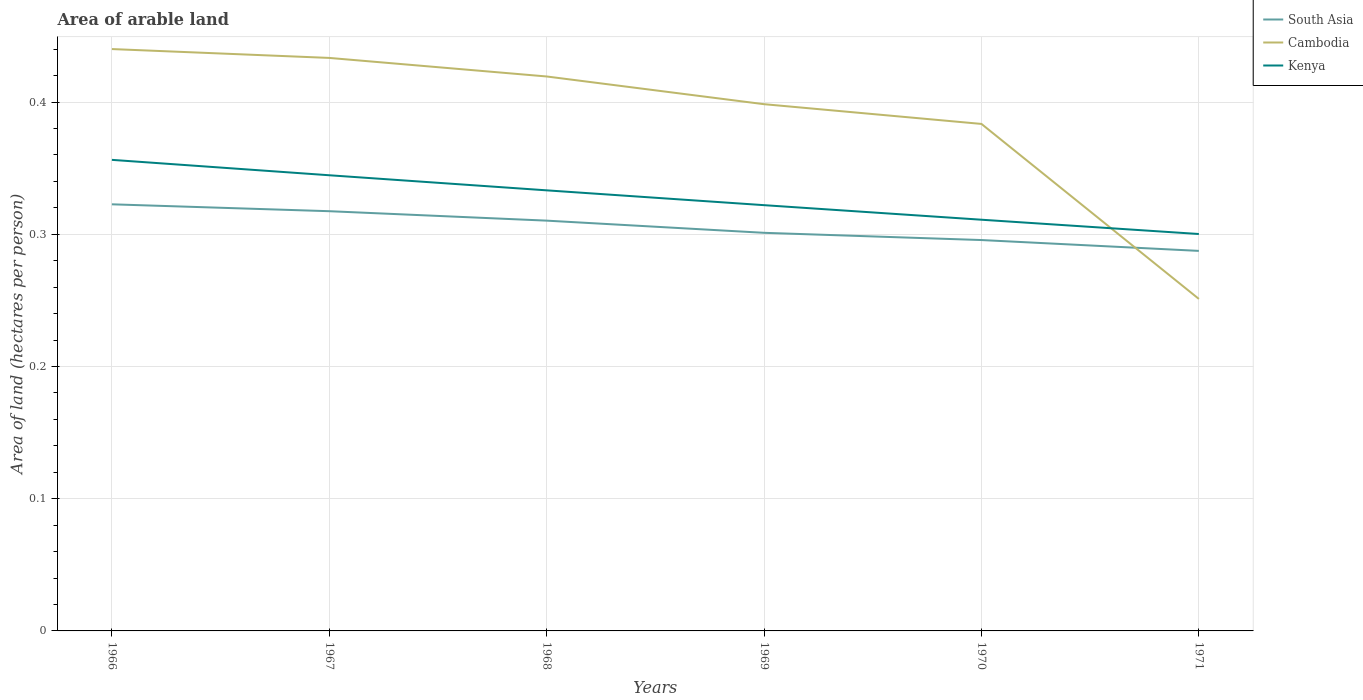Does the line corresponding to Kenya intersect with the line corresponding to South Asia?
Offer a very short reply. No. Across all years, what is the maximum total arable land in South Asia?
Your answer should be compact. 0.29. In which year was the total arable land in Kenya maximum?
Your answer should be compact. 1971. What is the total total arable land in South Asia in the graph?
Your response must be concise. 0.04. What is the difference between the highest and the second highest total arable land in Kenya?
Offer a very short reply. 0.06. Is the total arable land in Kenya strictly greater than the total arable land in Cambodia over the years?
Your response must be concise. No. How many lines are there?
Your response must be concise. 3. How many years are there in the graph?
Keep it short and to the point. 6. Does the graph contain grids?
Provide a short and direct response. Yes. Where does the legend appear in the graph?
Ensure brevity in your answer.  Top right. How are the legend labels stacked?
Provide a succinct answer. Vertical. What is the title of the graph?
Ensure brevity in your answer.  Area of arable land. Does "Pacific island small states" appear as one of the legend labels in the graph?
Offer a terse response. No. What is the label or title of the X-axis?
Your answer should be very brief. Years. What is the label or title of the Y-axis?
Your response must be concise. Area of land (hectares per person). What is the Area of land (hectares per person) in South Asia in 1966?
Offer a very short reply. 0.32. What is the Area of land (hectares per person) in Cambodia in 1966?
Ensure brevity in your answer.  0.44. What is the Area of land (hectares per person) of Kenya in 1966?
Make the answer very short. 0.36. What is the Area of land (hectares per person) of South Asia in 1967?
Ensure brevity in your answer.  0.32. What is the Area of land (hectares per person) in Cambodia in 1967?
Offer a terse response. 0.43. What is the Area of land (hectares per person) in Kenya in 1967?
Offer a very short reply. 0.34. What is the Area of land (hectares per person) in South Asia in 1968?
Your answer should be compact. 0.31. What is the Area of land (hectares per person) of Cambodia in 1968?
Keep it short and to the point. 0.42. What is the Area of land (hectares per person) of Kenya in 1968?
Your answer should be compact. 0.33. What is the Area of land (hectares per person) in South Asia in 1969?
Offer a very short reply. 0.3. What is the Area of land (hectares per person) of Cambodia in 1969?
Give a very brief answer. 0.4. What is the Area of land (hectares per person) in Kenya in 1969?
Offer a very short reply. 0.32. What is the Area of land (hectares per person) of South Asia in 1970?
Ensure brevity in your answer.  0.3. What is the Area of land (hectares per person) in Cambodia in 1970?
Your answer should be compact. 0.38. What is the Area of land (hectares per person) in Kenya in 1970?
Your answer should be very brief. 0.31. What is the Area of land (hectares per person) in South Asia in 1971?
Provide a short and direct response. 0.29. What is the Area of land (hectares per person) of Cambodia in 1971?
Offer a very short reply. 0.25. What is the Area of land (hectares per person) in Kenya in 1971?
Ensure brevity in your answer.  0.3. Across all years, what is the maximum Area of land (hectares per person) in South Asia?
Keep it short and to the point. 0.32. Across all years, what is the maximum Area of land (hectares per person) in Cambodia?
Provide a short and direct response. 0.44. Across all years, what is the maximum Area of land (hectares per person) in Kenya?
Your answer should be compact. 0.36. Across all years, what is the minimum Area of land (hectares per person) in South Asia?
Provide a short and direct response. 0.29. Across all years, what is the minimum Area of land (hectares per person) of Cambodia?
Your answer should be compact. 0.25. Across all years, what is the minimum Area of land (hectares per person) in Kenya?
Offer a very short reply. 0.3. What is the total Area of land (hectares per person) of South Asia in the graph?
Offer a very short reply. 1.83. What is the total Area of land (hectares per person) of Cambodia in the graph?
Provide a short and direct response. 2.33. What is the total Area of land (hectares per person) of Kenya in the graph?
Your response must be concise. 1.97. What is the difference between the Area of land (hectares per person) of South Asia in 1966 and that in 1967?
Your answer should be very brief. 0.01. What is the difference between the Area of land (hectares per person) in Cambodia in 1966 and that in 1967?
Keep it short and to the point. 0.01. What is the difference between the Area of land (hectares per person) of Kenya in 1966 and that in 1967?
Offer a terse response. 0.01. What is the difference between the Area of land (hectares per person) in South Asia in 1966 and that in 1968?
Your answer should be compact. 0.01. What is the difference between the Area of land (hectares per person) of Cambodia in 1966 and that in 1968?
Provide a short and direct response. 0.02. What is the difference between the Area of land (hectares per person) in Kenya in 1966 and that in 1968?
Offer a terse response. 0.02. What is the difference between the Area of land (hectares per person) in South Asia in 1966 and that in 1969?
Provide a succinct answer. 0.02. What is the difference between the Area of land (hectares per person) of Cambodia in 1966 and that in 1969?
Your answer should be very brief. 0.04. What is the difference between the Area of land (hectares per person) of Kenya in 1966 and that in 1969?
Make the answer very short. 0.03. What is the difference between the Area of land (hectares per person) in South Asia in 1966 and that in 1970?
Provide a succinct answer. 0.03. What is the difference between the Area of land (hectares per person) in Cambodia in 1966 and that in 1970?
Offer a very short reply. 0.06. What is the difference between the Area of land (hectares per person) in Kenya in 1966 and that in 1970?
Make the answer very short. 0.05. What is the difference between the Area of land (hectares per person) in South Asia in 1966 and that in 1971?
Keep it short and to the point. 0.04. What is the difference between the Area of land (hectares per person) of Cambodia in 1966 and that in 1971?
Your answer should be very brief. 0.19. What is the difference between the Area of land (hectares per person) in Kenya in 1966 and that in 1971?
Offer a terse response. 0.06. What is the difference between the Area of land (hectares per person) in South Asia in 1967 and that in 1968?
Make the answer very short. 0.01. What is the difference between the Area of land (hectares per person) in Cambodia in 1967 and that in 1968?
Keep it short and to the point. 0.01. What is the difference between the Area of land (hectares per person) in Kenya in 1967 and that in 1968?
Your response must be concise. 0.01. What is the difference between the Area of land (hectares per person) in South Asia in 1967 and that in 1969?
Give a very brief answer. 0.02. What is the difference between the Area of land (hectares per person) of Cambodia in 1967 and that in 1969?
Your answer should be compact. 0.04. What is the difference between the Area of land (hectares per person) of Kenya in 1967 and that in 1969?
Your answer should be very brief. 0.02. What is the difference between the Area of land (hectares per person) in South Asia in 1967 and that in 1970?
Provide a succinct answer. 0.02. What is the difference between the Area of land (hectares per person) of Cambodia in 1967 and that in 1970?
Provide a succinct answer. 0.05. What is the difference between the Area of land (hectares per person) of Kenya in 1967 and that in 1970?
Your answer should be compact. 0.03. What is the difference between the Area of land (hectares per person) of Cambodia in 1967 and that in 1971?
Offer a very short reply. 0.18. What is the difference between the Area of land (hectares per person) in Kenya in 1967 and that in 1971?
Give a very brief answer. 0.04. What is the difference between the Area of land (hectares per person) in South Asia in 1968 and that in 1969?
Offer a very short reply. 0.01. What is the difference between the Area of land (hectares per person) in Cambodia in 1968 and that in 1969?
Your response must be concise. 0.02. What is the difference between the Area of land (hectares per person) in Kenya in 1968 and that in 1969?
Keep it short and to the point. 0.01. What is the difference between the Area of land (hectares per person) in South Asia in 1968 and that in 1970?
Ensure brevity in your answer.  0.01. What is the difference between the Area of land (hectares per person) in Cambodia in 1968 and that in 1970?
Make the answer very short. 0.04. What is the difference between the Area of land (hectares per person) in Kenya in 1968 and that in 1970?
Ensure brevity in your answer.  0.02. What is the difference between the Area of land (hectares per person) in South Asia in 1968 and that in 1971?
Provide a succinct answer. 0.02. What is the difference between the Area of land (hectares per person) of Cambodia in 1968 and that in 1971?
Offer a terse response. 0.17. What is the difference between the Area of land (hectares per person) of Kenya in 1968 and that in 1971?
Your response must be concise. 0.03. What is the difference between the Area of land (hectares per person) of South Asia in 1969 and that in 1970?
Provide a short and direct response. 0.01. What is the difference between the Area of land (hectares per person) in Cambodia in 1969 and that in 1970?
Your answer should be compact. 0.01. What is the difference between the Area of land (hectares per person) of Kenya in 1969 and that in 1970?
Offer a very short reply. 0.01. What is the difference between the Area of land (hectares per person) of South Asia in 1969 and that in 1971?
Make the answer very short. 0.01. What is the difference between the Area of land (hectares per person) of Cambodia in 1969 and that in 1971?
Provide a short and direct response. 0.15. What is the difference between the Area of land (hectares per person) in Kenya in 1969 and that in 1971?
Ensure brevity in your answer.  0.02. What is the difference between the Area of land (hectares per person) in South Asia in 1970 and that in 1971?
Provide a succinct answer. 0.01. What is the difference between the Area of land (hectares per person) in Cambodia in 1970 and that in 1971?
Give a very brief answer. 0.13. What is the difference between the Area of land (hectares per person) in Kenya in 1970 and that in 1971?
Offer a very short reply. 0.01. What is the difference between the Area of land (hectares per person) of South Asia in 1966 and the Area of land (hectares per person) of Cambodia in 1967?
Keep it short and to the point. -0.11. What is the difference between the Area of land (hectares per person) of South Asia in 1966 and the Area of land (hectares per person) of Kenya in 1967?
Offer a terse response. -0.02. What is the difference between the Area of land (hectares per person) of Cambodia in 1966 and the Area of land (hectares per person) of Kenya in 1967?
Your answer should be compact. 0.1. What is the difference between the Area of land (hectares per person) of South Asia in 1966 and the Area of land (hectares per person) of Cambodia in 1968?
Provide a short and direct response. -0.1. What is the difference between the Area of land (hectares per person) of South Asia in 1966 and the Area of land (hectares per person) of Kenya in 1968?
Make the answer very short. -0.01. What is the difference between the Area of land (hectares per person) of Cambodia in 1966 and the Area of land (hectares per person) of Kenya in 1968?
Keep it short and to the point. 0.11. What is the difference between the Area of land (hectares per person) in South Asia in 1966 and the Area of land (hectares per person) in Cambodia in 1969?
Provide a short and direct response. -0.08. What is the difference between the Area of land (hectares per person) in South Asia in 1966 and the Area of land (hectares per person) in Kenya in 1969?
Ensure brevity in your answer.  0. What is the difference between the Area of land (hectares per person) of Cambodia in 1966 and the Area of land (hectares per person) of Kenya in 1969?
Offer a terse response. 0.12. What is the difference between the Area of land (hectares per person) in South Asia in 1966 and the Area of land (hectares per person) in Cambodia in 1970?
Make the answer very short. -0.06. What is the difference between the Area of land (hectares per person) of South Asia in 1966 and the Area of land (hectares per person) of Kenya in 1970?
Provide a succinct answer. 0.01. What is the difference between the Area of land (hectares per person) in Cambodia in 1966 and the Area of land (hectares per person) in Kenya in 1970?
Provide a short and direct response. 0.13. What is the difference between the Area of land (hectares per person) of South Asia in 1966 and the Area of land (hectares per person) of Cambodia in 1971?
Provide a succinct answer. 0.07. What is the difference between the Area of land (hectares per person) of South Asia in 1966 and the Area of land (hectares per person) of Kenya in 1971?
Offer a very short reply. 0.02. What is the difference between the Area of land (hectares per person) in Cambodia in 1966 and the Area of land (hectares per person) in Kenya in 1971?
Your answer should be very brief. 0.14. What is the difference between the Area of land (hectares per person) of South Asia in 1967 and the Area of land (hectares per person) of Cambodia in 1968?
Provide a succinct answer. -0.1. What is the difference between the Area of land (hectares per person) in South Asia in 1967 and the Area of land (hectares per person) in Kenya in 1968?
Offer a very short reply. -0.02. What is the difference between the Area of land (hectares per person) of Cambodia in 1967 and the Area of land (hectares per person) of Kenya in 1968?
Your answer should be compact. 0.1. What is the difference between the Area of land (hectares per person) of South Asia in 1967 and the Area of land (hectares per person) of Cambodia in 1969?
Make the answer very short. -0.08. What is the difference between the Area of land (hectares per person) in South Asia in 1967 and the Area of land (hectares per person) in Kenya in 1969?
Give a very brief answer. -0. What is the difference between the Area of land (hectares per person) of Cambodia in 1967 and the Area of land (hectares per person) of Kenya in 1969?
Make the answer very short. 0.11. What is the difference between the Area of land (hectares per person) in South Asia in 1967 and the Area of land (hectares per person) in Cambodia in 1970?
Your answer should be compact. -0.07. What is the difference between the Area of land (hectares per person) of South Asia in 1967 and the Area of land (hectares per person) of Kenya in 1970?
Ensure brevity in your answer.  0.01. What is the difference between the Area of land (hectares per person) in Cambodia in 1967 and the Area of land (hectares per person) in Kenya in 1970?
Offer a very short reply. 0.12. What is the difference between the Area of land (hectares per person) of South Asia in 1967 and the Area of land (hectares per person) of Cambodia in 1971?
Keep it short and to the point. 0.07. What is the difference between the Area of land (hectares per person) in South Asia in 1967 and the Area of land (hectares per person) in Kenya in 1971?
Keep it short and to the point. 0.02. What is the difference between the Area of land (hectares per person) of Cambodia in 1967 and the Area of land (hectares per person) of Kenya in 1971?
Offer a terse response. 0.13. What is the difference between the Area of land (hectares per person) of South Asia in 1968 and the Area of land (hectares per person) of Cambodia in 1969?
Make the answer very short. -0.09. What is the difference between the Area of land (hectares per person) of South Asia in 1968 and the Area of land (hectares per person) of Kenya in 1969?
Your response must be concise. -0.01. What is the difference between the Area of land (hectares per person) in Cambodia in 1968 and the Area of land (hectares per person) in Kenya in 1969?
Offer a very short reply. 0.1. What is the difference between the Area of land (hectares per person) of South Asia in 1968 and the Area of land (hectares per person) of Cambodia in 1970?
Give a very brief answer. -0.07. What is the difference between the Area of land (hectares per person) of South Asia in 1968 and the Area of land (hectares per person) of Kenya in 1970?
Offer a terse response. -0. What is the difference between the Area of land (hectares per person) of Cambodia in 1968 and the Area of land (hectares per person) of Kenya in 1970?
Provide a succinct answer. 0.11. What is the difference between the Area of land (hectares per person) in South Asia in 1968 and the Area of land (hectares per person) in Cambodia in 1971?
Offer a very short reply. 0.06. What is the difference between the Area of land (hectares per person) of South Asia in 1968 and the Area of land (hectares per person) of Kenya in 1971?
Your answer should be compact. 0.01. What is the difference between the Area of land (hectares per person) of Cambodia in 1968 and the Area of land (hectares per person) of Kenya in 1971?
Provide a short and direct response. 0.12. What is the difference between the Area of land (hectares per person) of South Asia in 1969 and the Area of land (hectares per person) of Cambodia in 1970?
Offer a terse response. -0.08. What is the difference between the Area of land (hectares per person) of South Asia in 1969 and the Area of land (hectares per person) of Kenya in 1970?
Provide a short and direct response. -0.01. What is the difference between the Area of land (hectares per person) in Cambodia in 1969 and the Area of land (hectares per person) in Kenya in 1970?
Make the answer very short. 0.09. What is the difference between the Area of land (hectares per person) in South Asia in 1969 and the Area of land (hectares per person) in Cambodia in 1971?
Offer a terse response. 0.05. What is the difference between the Area of land (hectares per person) in South Asia in 1969 and the Area of land (hectares per person) in Kenya in 1971?
Your answer should be compact. 0. What is the difference between the Area of land (hectares per person) of Cambodia in 1969 and the Area of land (hectares per person) of Kenya in 1971?
Your answer should be compact. 0.1. What is the difference between the Area of land (hectares per person) of South Asia in 1970 and the Area of land (hectares per person) of Cambodia in 1971?
Your response must be concise. 0.04. What is the difference between the Area of land (hectares per person) of South Asia in 1970 and the Area of land (hectares per person) of Kenya in 1971?
Your answer should be compact. -0. What is the difference between the Area of land (hectares per person) of Cambodia in 1970 and the Area of land (hectares per person) of Kenya in 1971?
Ensure brevity in your answer.  0.08. What is the average Area of land (hectares per person) of South Asia per year?
Keep it short and to the point. 0.31. What is the average Area of land (hectares per person) of Cambodia per year?
Your answer should be very brief. 0.39. What is the average Area of land (hectares per person) in Kenya per year?
Your response must be concise. 0.33. In the year 1966, what is the difference between the Area of land (hectares per person) in South Asia and Area of land (hectares per person) in Cambodia?
Give a very brief answer. -0.12. In the year 1966, what is the difference between the Area of land (hectares per person) in South Asia and Area of land (hectares per person) in Kenya?
Your response must be concise. -0.03. In the year 1966, what is the difference between the Area of land (hectares per person) in Cambodia and Area of land (hectares per person) in Kenya?
Your answer should be compact. 0.08. In the year 1967, what is the difference between the Area of land (hectares per person) in South Asia and Area of land (hectares per person) in Cambodia?
Your answer should be very brief. -0.12. In the year 1967, what is the difference between the Area of land (hectares per person) of South Asia and Area of land (hectares per person) of Kenya?
Your answer should be compact. -0.03. In the year 1967, what is the difference between the Area of land (hectares per person) in Cambodia and Area of land (hectares per person) in Kenya?
Provide a short and direct response. 0.09. In the year 1968, what is the difference between the Area of land (hectares per person) in South Asia and Area of land (hectares per person) in Cambodia?
Ensure brevity in your answer.  -0.11. In the year 1968, what is the difference between the Area of land (hectares per person) in South Asia and Area of land (hectares per person) in Kenya?
Ensure brevity in your answer.  -0.02. In the year 1968, what is the difference between the Area of land (hectares per person) in Cambodia and Area of land (hectares per person) in Kenya?
Provide a short and direct response. 0.09. In the year 1969, what is the difference between the Area of land (hectares per person) of South Asia and Area of land (hectares per person) of Cambodia?
Provide a short and direct response. -0.1. In the year 1969, what is the difference between the Area of land (hectares per person) of South Asia and Area of land (hectares per person) of Kenya?
Your answer should be compact. -0.02. In the year 1969, what is the difference between the Area of land (hectares per person) of Cambodia and Area of land (hectares per person) of Kenya?
Offer a terse response. 0.08. In the year 1970, what is the difference between the Area of land (hectares per person) in South Asia and Area of land (hectares per person) in Cambodia?
Ensure brevity in your answer.  -0.09. In the year 1970, what is the difference between the Area of land (hectares per person) in South Asia and Area of land (hectares per person) in Kenya?
Give a very brief answer. -0.02. In the year 1970, what is the difference between the Area of land (hectares per person) in Cambodia and Area of land (hectares per person) in Kenya?
Provide a short and direct response. 0.07. In the year 1971, what is the difference between the Area of land (hectares per person) in South Asia and Area of land (hectares per person) in Cambodia?
Make the answer very short. 0.04. In the year 1971, what is the difference between the Area of land (hectares per person) in South Asia and Area of land (hectares per person) in Kenya?
Provide a short and direct response. -0.01. In the year 1971, what is the difference between the Area of land (hectares per person) of Cambodia and Area of land (hectares per person) of Kenya?
Offer a terse response. -0.05. What is the ratio of the Area of land (hectares per person) of South Asia in 1966 to that in 1967?
Your response must be concise. 1.02. What is the ratio of the Area of land (hectares per person) of Cambodia in 1966 to that in 1967?
Provide a short and direct response. 1.02. What is the ratio of the Area of land (hectares per person) of Kenya in 1966 to that in 1967?
Your response must be concise. 1.03. What is the ratio of the Area of land (hectares per person) in South Asia in 1966 to that in 1968?
Provide a succinct answer. 1.04. What is the ratio of the Area of land (hectares per person) in Cambodia in 1966 to that in 1968?
Your answer should be compact. 1.05. What is the ratio of the Area of land (hectares per person) in Kenya in 1966 to that in 1968?
Offer a terse response. 1.07. What is the ratio of the Area of land (hectares per person) in South Asia in 1966 to that in 1969?
Make the answer very short. 1.07. What is the ratio of the Area of land (hectares per person) in Cambodia in 1966 to that in 1969?
Provide a short and direct response. 1.1. What is the ratio of the Area of land (hectares per person) in Kenya in 1966 to that in 1969?
Make the answer very short. 1.11. What is the ratio of the Area of land (hectares per person) of South Asia in 1966 to that in 1970?
Keep it short and to the point. 1.09. What is the ratio of the Area of land (hectares per person) in Cambodia in 1966 to that in 1970?
Offer a very short reply. 1.15. What is the ratio of the Area of land (hectares per person) of Kenya in 1966 to that in 1970?
Your answer should be compact. 1.15. What is the ratio of the Area of land (hectares per person) in South Asia in 1966 to that in 1971?
Your answer should be compact. 1.12. What is the ratio of the Area of land (hectares per person) in Cambodia in 1966 to that in 1971?
Provide a succinct answer. 1.75. What is the ratio of the Area of land (hectares per person) of Kenya in 1966 to that in 1971?
Give a very brief answer. 1.19. What is the ratio of the Area of land (hectares per person) of South Asia in 1967 to that in 1968?
Make the answer very short. 1.02. What is the ratio of the Area of land (hectares per person) of Cambodia in 1967 to that in 1968?
Provide a short and direct response. 1.03. What is the ratio of the Area of land (hectares per person) of Kenya in 1967 to that in 1968?
Provide a short and direct response. 1.03. What is the ratio of the Area of land (hectares per person) in South Asia in 1967 to that in 1969?
Give a very brief answer. 1.05. What is the ratio of the Area of land (hectares per person) in Cambodia in 1967 to that in 1969?
Give a very brief answer. 1.09. What is the ratio of the Area of land (hectares per person) in Kenya in 1967 to that in 1969?
Ensure brevity in your answer.  1.07. What is the ratio of the Area of land (hectares per person) of South Asia in 1967 to that in 1970?
Provide a short and direct response. 1.07. What is the ratio of the Area of land (hectares per person) of Cambodia in 1967 to that in 1970?
Provide a short and direct response. 1.13. What is the ratio of the Area of land (hectares per person) in Kenya in 1967 to that in 1970?
Offer a terse response. 1.11. What is the ratio of the Area of land (hectares per person) in South Asia in 1967 to that in 1971?
Offer a very short reply. 1.1. What is the ratio of the Area of land (hectares per person) in Cambodia in 1967 to that in 1971?
Ensure brevity in your answer.  1.73. What is the ratio of the Area of land (hectares per person) in Kenya in 1967 to that in 1971?
Your response must be concise. 1.15. What is the ratio of the Area of land (hectares per person) in South Asia in 1968 to that in 1969?
Your answer should be compact. 1.03. What is the ratio of the Area of land (hectares per person) of Cambodia in 1968 to that in 1969?
Offer a terse response. 1.05. What is the ratio of the Area of land (hectares per person) of Kenya in 1968 to that in 1969?
Provide a succinct answer. 1.03. What is the ratio of the Area of land (hectares per person) of South Asia in 1968 to that in 1970?
Your answer should be compact. 1.05. What is the ratio of the Area of land (hectares per person) in Cambodia in 1968 to that in 1970?
Make the answer very short. 1.09. What is the ratio of the Area of land (hectares per person) in Kenya in 1968 to that in 1970?
Your answer should be very brief. 1.07. What is the ratio of the Area of land (hectares per person) in South Asia in 1968 to that in 1971?
Make the answer very short. 1.08. What is the ratio of the Area of land (hectares per person) of Cambodia in 1968 to that in 1971?
Your answer should be very brief. 1.67. What is the ratio of the Area of land (hectares per person) of Kenya in 1968 to that in 1971?
Ensure brevity in your answer.  1.11. What is the ratio of the Area of land (hectares per person) of South Asia in 1969 to that in 1970?
Your answer should be compact. 1.02. What is the ratio of the Area of land (hectares per person) of Cambodia in 1969 to that in 1970?
Provide a succinct answer. 1.04. What is the ratio of the Area of land (hectares per person) of Kenya in 1969 to that in 1970?
Provide a short and direct response. 1.04. What is the ratio of the Area of land (hectares per person) in South Asia in 1969 to that in 1971?
Make the answer very short. 1.05. What is the ratio of the Area of land (hectares per person) of Cambodia in 1969 to that in 1971?
Your response must be concise. 1.59. What is the ratio of the Area of land (hectares per person) in Kenya in 1969 to that in 1971?
Give a very brief answer. 1.07. What is the ratio of the Area of land (hectares per person) of South Asia in 1970 to that in 1971?
Offer a terse response. 1.03. What is the ratio of the Area of land (hectares per person) of Cambodia in 1970 to that in 1971?
Your answer should be very brief. 1.53. What is the ratio of the Area of land (hectares per person) of Kenya in 1970 to that in 1971?
Your response must be concise. 1.04. What is the difference between the highest and the second highest Area of land (hectares per person) in South Asia?
Provide a short and direct response. 0.01. What is the difference between the highest and the second highest Area of land (hectares per person) of Cambodia?
Offer a terse response. 0.01. What is the difference between the highest and the second highest Area of land (hectares per person) of Kenya?
Make the answer very short. 0.01. What is the difference between the highest and the lowest Area of land (hectares per person) of South Asia?
Your answer should be compact. 0.04. What is the difference between the highest and the lowest Area of land (hectares per person) in Cambodia?
Provide a succinct answer. 0.19. What is the difference between the highest and the lowest Area of land (hectares per person) of Kenya?
Offer a terse response. 0.06. 